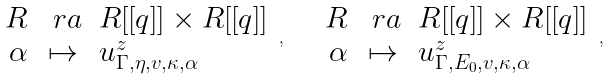Convert formula to latex. <formula><loc_0><loc_0><loc_500><loc_500>\begin{array} { r c l } R & \ r a & R [ [ q ] ] \times R [ [ q ] ] \\ \alpha & \mapsto & u ^ { z } _ { \Gamma , \eta , v , \kappa , \alpha } \\ \end{array} \, , \quad \begin{array} { r c l } R & \ r a & R [ [ q ] ] \times R [ [ q ] ] \\ \alpha & \mapsto & u ^ { z } _ { \Gamma , E _ { 0 } , v , \kappa , \alpha } \end{array} \, ,</formula> 